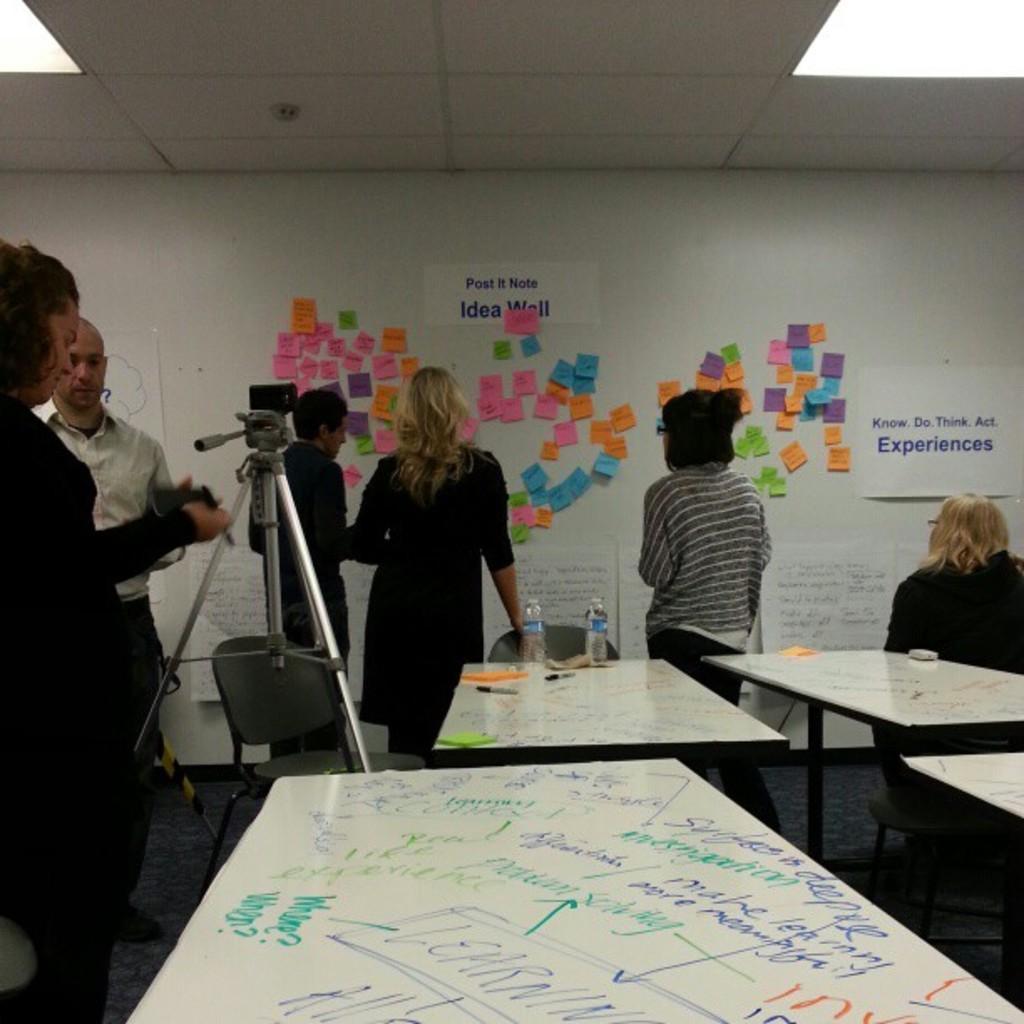Describe this image in one or two sentences. In this image i can see few persons standing and a person sitting on the chair. In the background i can see the wall , the ceiling and few sticky notes attached to the wall. I can see few tables on which i can see few bottles, few papers and few pens. I can see a camera stand and a camera attached to it. 